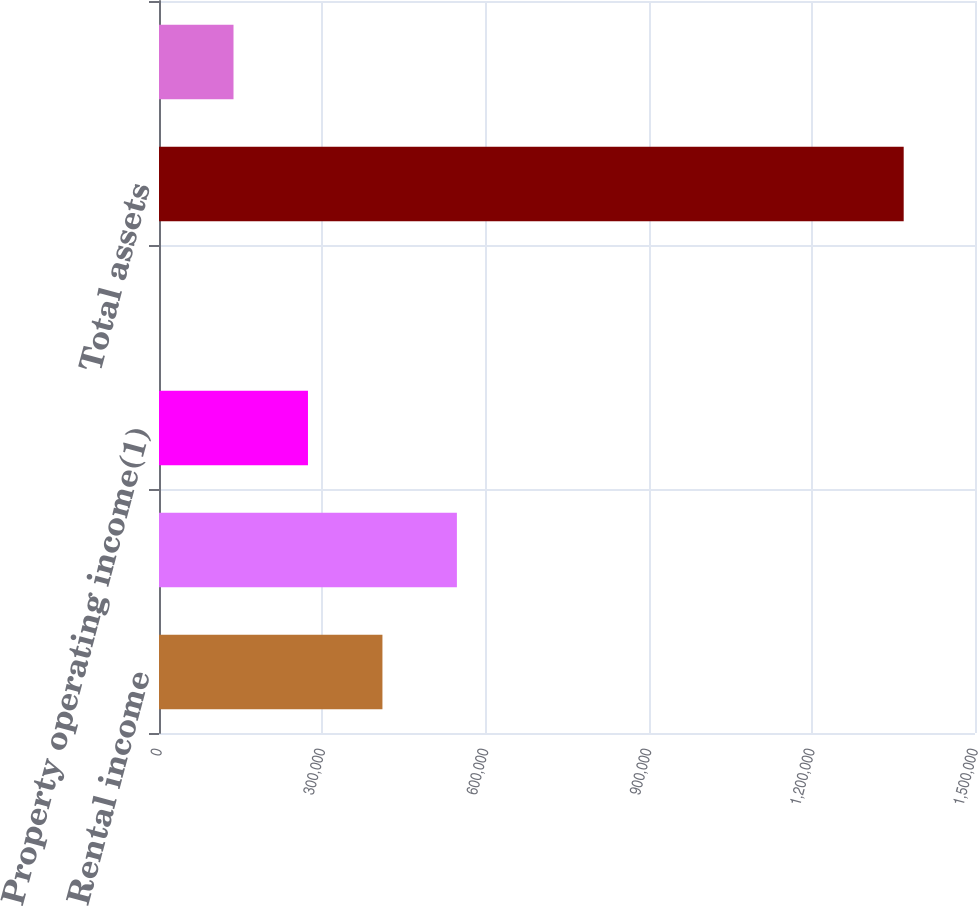<chart> <loc_0><loc_0><loc_500><loc_500><bar_chart><fcel>Rental income<fcel>Total revenue<fcel>Property operating income(1)<fcel>Property operating income as a<fcel>Total assets<fcel>Gross leasable square feet<nl><fcel>410727<fcel>547613<fcel>273842<fcel>71.3<fcel>1.36892e+06<fcel>136957<nl></chart> 